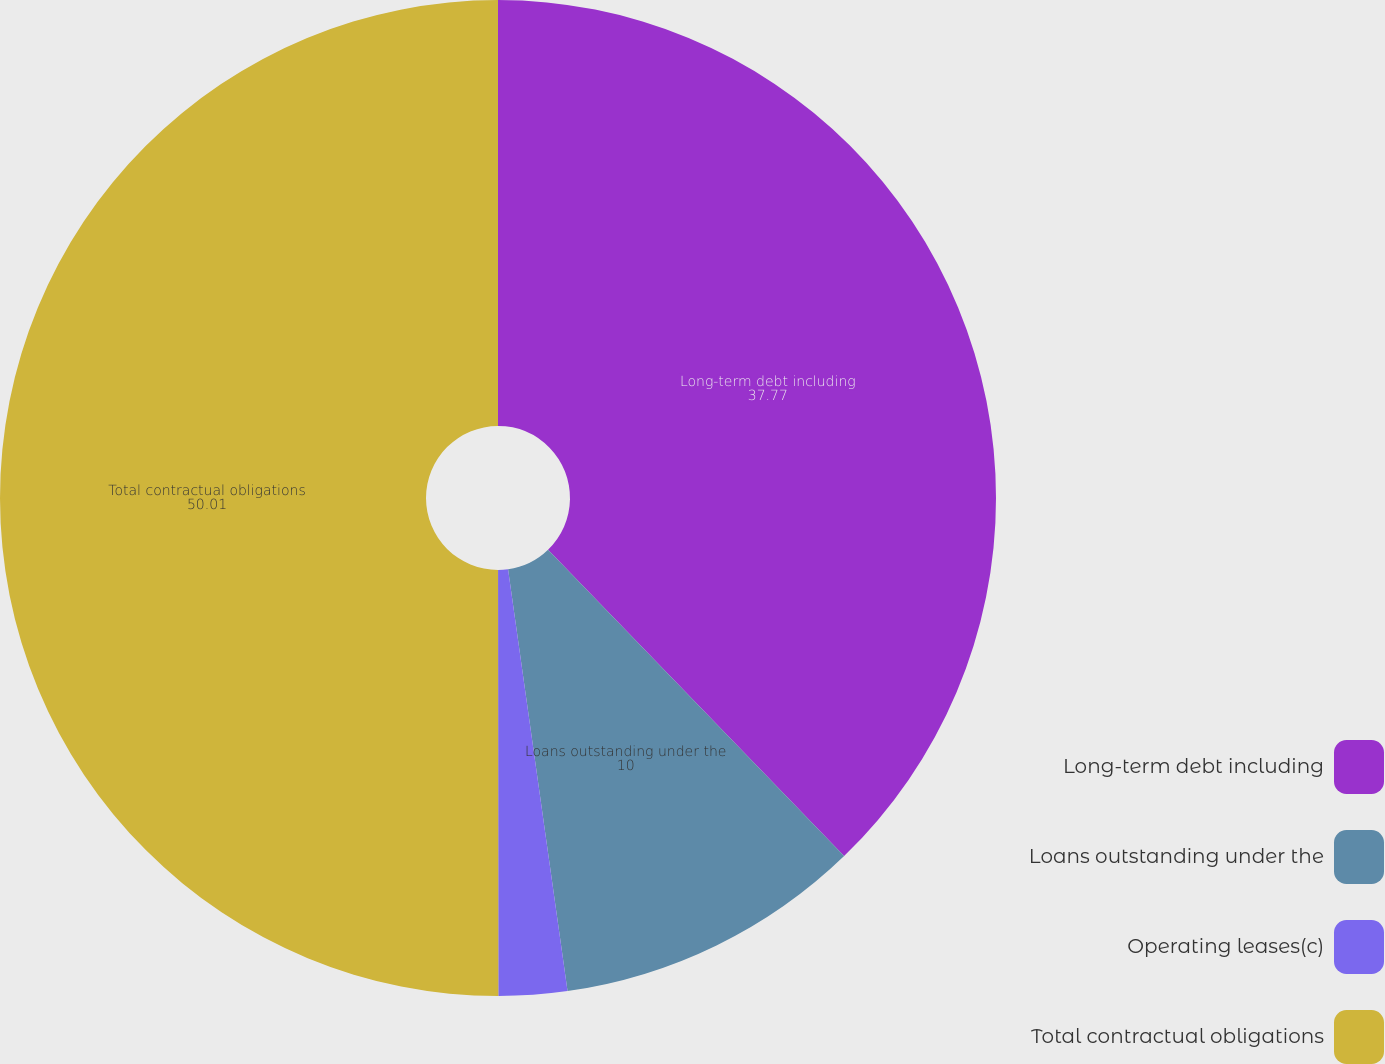<chart> <loc_0><loc_0><loc_500><loc_500><pie_chart><fcel>Long-term debt including<fcel>Loans outstanding under the<fcel>Operating leases(c)<fcel>Total contractual obligations<nl><fcel>37.77%<fcel>10.0%<fcel>2.22%<fcel>50.01%<nl></chart> 